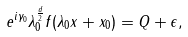Convert formula to latex. <formula><loc_0><loc_0><loc_500><loc_500>e ^ { i \gamma _ { 0 } } \lambda _ { 0 } ^ { \frac { d } { 2 } } f ( \lambda _ { 0 } x + x _ { 0 } ) = Q + \epsilon ,</formula> 